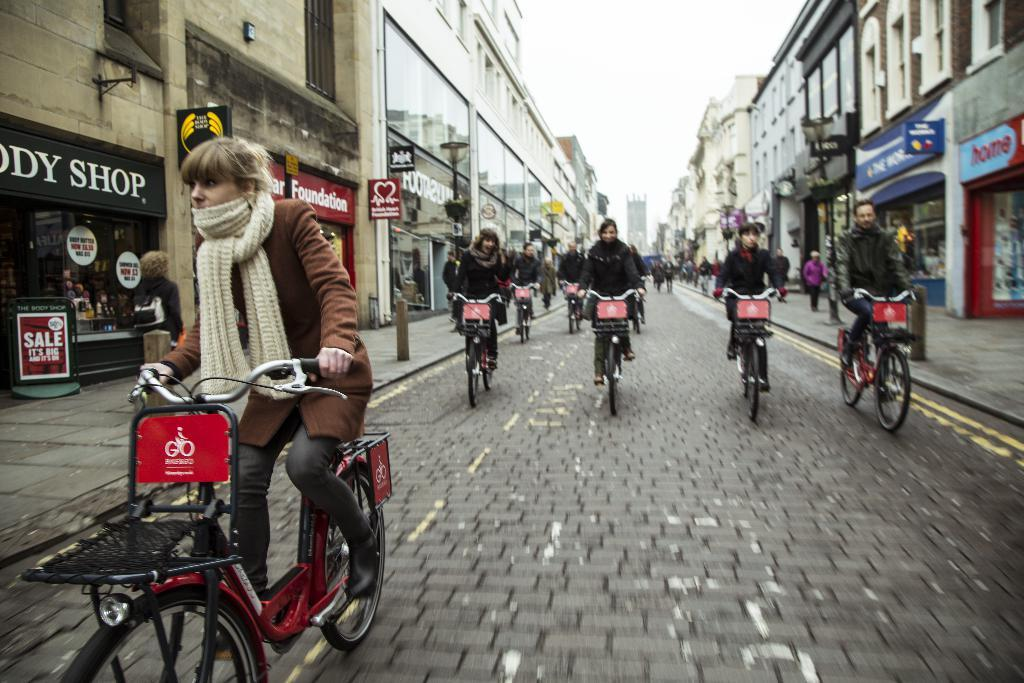What are the people in the image doing? The people in the image are cycling. What can be seen in the background of the image? There are buildings in the background of the image. What type of wine is being served at the event in the image? There is no event or wine present in the image; it features people cycling and buildings in the background. 